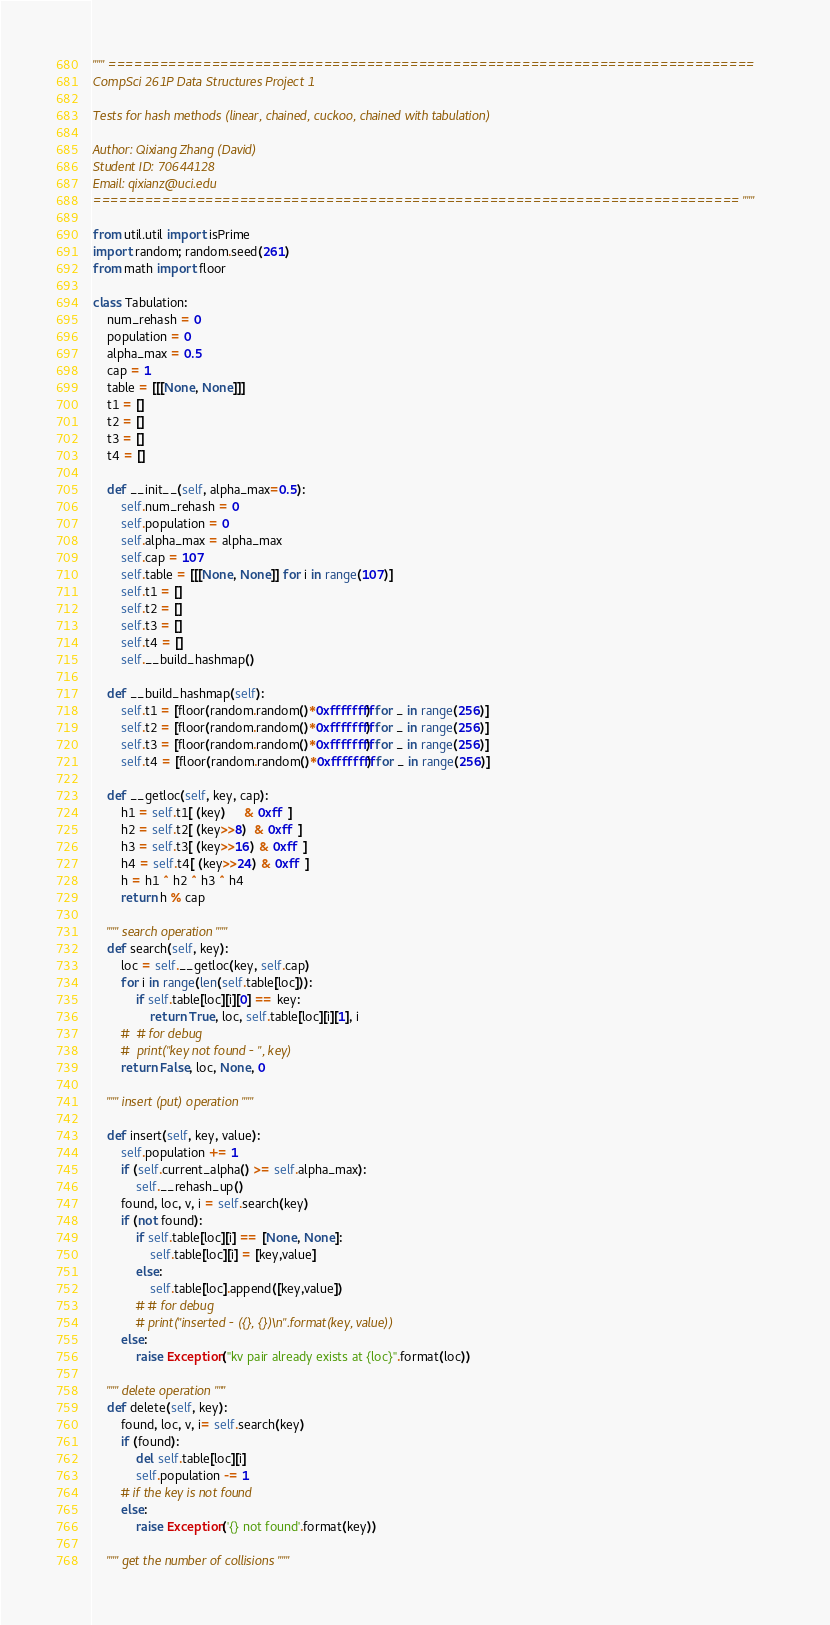<code> <loc_0><loc_0><loc_500><loc_500><_Python_>""" ===========================================================================
CompSci 261P Data Structures Project 1

Tests for hash methods (linear, chained, cuckoo, chained with tabulation)

Author: Qixiang Zhang (David)
Student ID: 70644128
Email: qixianz@uci.edu
=========================================================================== """

from util.util import isPrime
import random; random.seed(261)
from math import floor

class Tabulation:
    num_rehash = 0
    population = 0
    alpha_max = 0.5
    cap = 1
    table = [[[None, None]]]
    t1 = []
    t2 = []
    t3 = []
    t4 = []

    def __init__(self, alpha_max=0.5):
        self.num_rehash = 0
        self.population = 0
        self.alpha_max = alpha_max
        self.cap = 107
        self.table = [[[None, None]] for i in range(107)]
        self.t1 = []
        self.t2 = []
        self.t3 = []
        self.t4 = []
        self.__build_hashmap()

    def __build_hashmap(self):
        self.t1 = [floor(random.random()*0xffffffff) for _ in range(256)]
        self.t2 = [floor(random.random()*0xffffffff) for _ in range(256)]
        self.t3 = [floor(random.random()*0xffffffff) for _ in range(256)]
        self.t4 = [floor(random.random()*0xffffffff) for _ in range(256)]

    def __getloc(self, key, cap):
        h1 = self.t1[ (key)     & 0xff  ]
        h2 = self.t2[ (key>>8)  & 0xff  ]
        h3 = self.t3[ (key>>16) & 0xff  ]
        h4 = self.t4[ (key>>24) & 0xff  ]
        h = h1 ^ h2 ^ h3 ^ h4
        return h % cap
        
    """ search operation """
    def search(self, key):
        loc = self.__getloc(key, self.cap)
        for i in range(len(self.table[loc])):
            if self.table[loc][i][0] == key:
                return True, loc, self.table[loc][i][1], i
        #  # for debug
        #  print("key not found - ", key)
        return False, loc, None, 0
    
    """ insert (put) operation """

    def insert(self, key, value):
        self.population += 1
        if (self.current_alpha() >= self.alpha_max):
            self.__rehash_up()
        found, loc, v, i = self.search(key)
        if (not found):
            if self.table[loc][i] == [None, None]:
                self.table[loc][i] = [key,value]
            else:
                self.table[loc].append([key,value])
            # # for debug
            # print("inserted - ({}, {})\n".format(key, value))
        else:
            raise Exception("kv pair already exists at {loc}".format(loc))

    """ delete operation """ 
    def delete(self, key):
        found, loc, v, i= self.search(key)
        if (found):
            del self.table[loc][i]
            self.population -= 1
        # if the key is not found
        else:
            raise Exception('{} not found'.format(key))

    """ get the number of collisions """</code> 